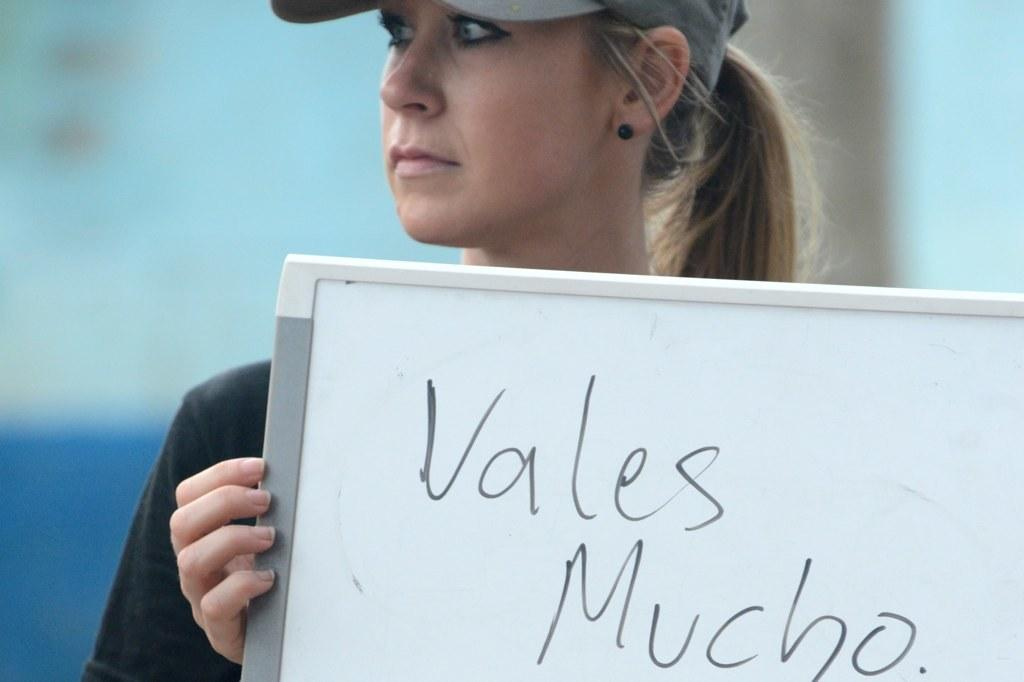Who is the main subject in the image? There is a woman in the image. What is the woman wearing on her head? The woman is wearing a hat. What is the woman holding in her hands? The woman is holding a board in her hands. What can be seen on the board? There is writing on the board. What type of cover is the woman using to protect herself from the rain in the image? There is no cover present in the image, and it does not depict rain. How many times does the woman fall while holding the board in the image? The woman does not fall in the image; she is standing still while holding the board. 